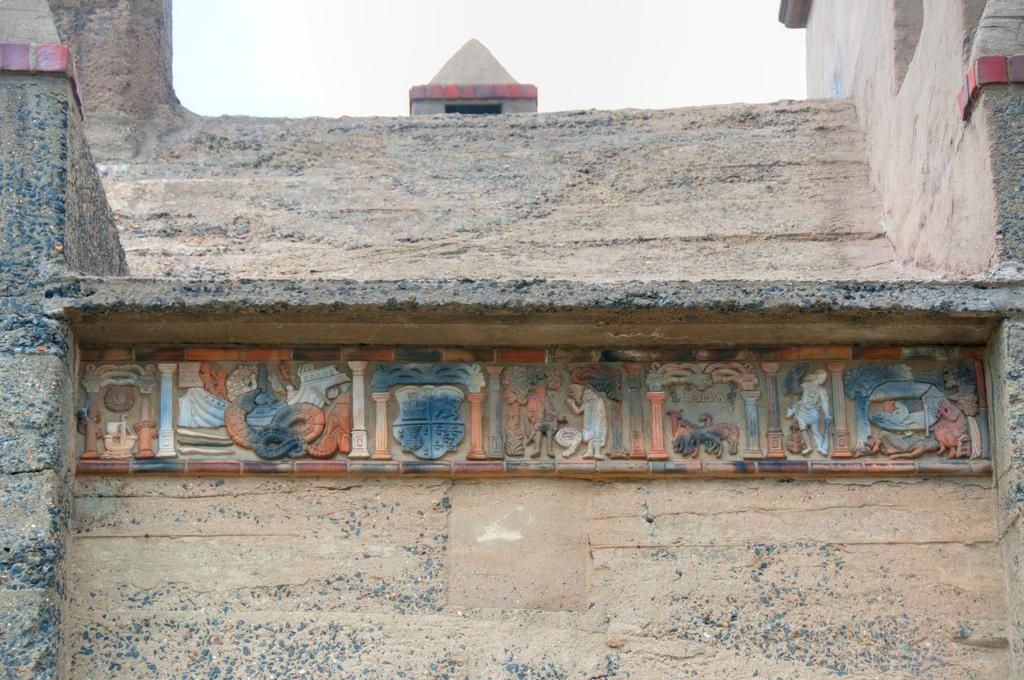What is present on the wall in the image? There is an art piece visible on the wall. What can be seen at the top of the image? The sky is visible at the top of the image. How does the wind affect the art piece on the wall in the image? There is no wind present in the image, and therefore it cannot affect the art piece. 